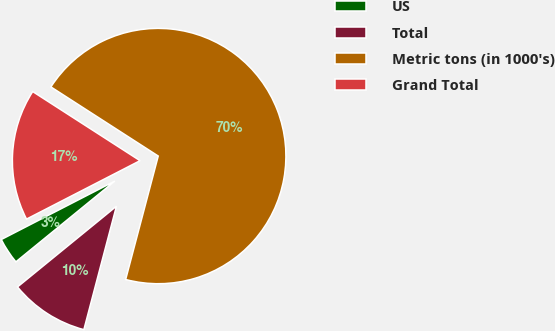<chart> <loc_0><loc_0><loc_500><loc_500><pie_chart><fcel>US<fcel>Total<fcel>Metric tons (in 1000's)<fcel>Grand Total<nl><fcel>3.33%<fcel>10.0%<fcel>70.0%<fcel>16.67%<nl></chart> 